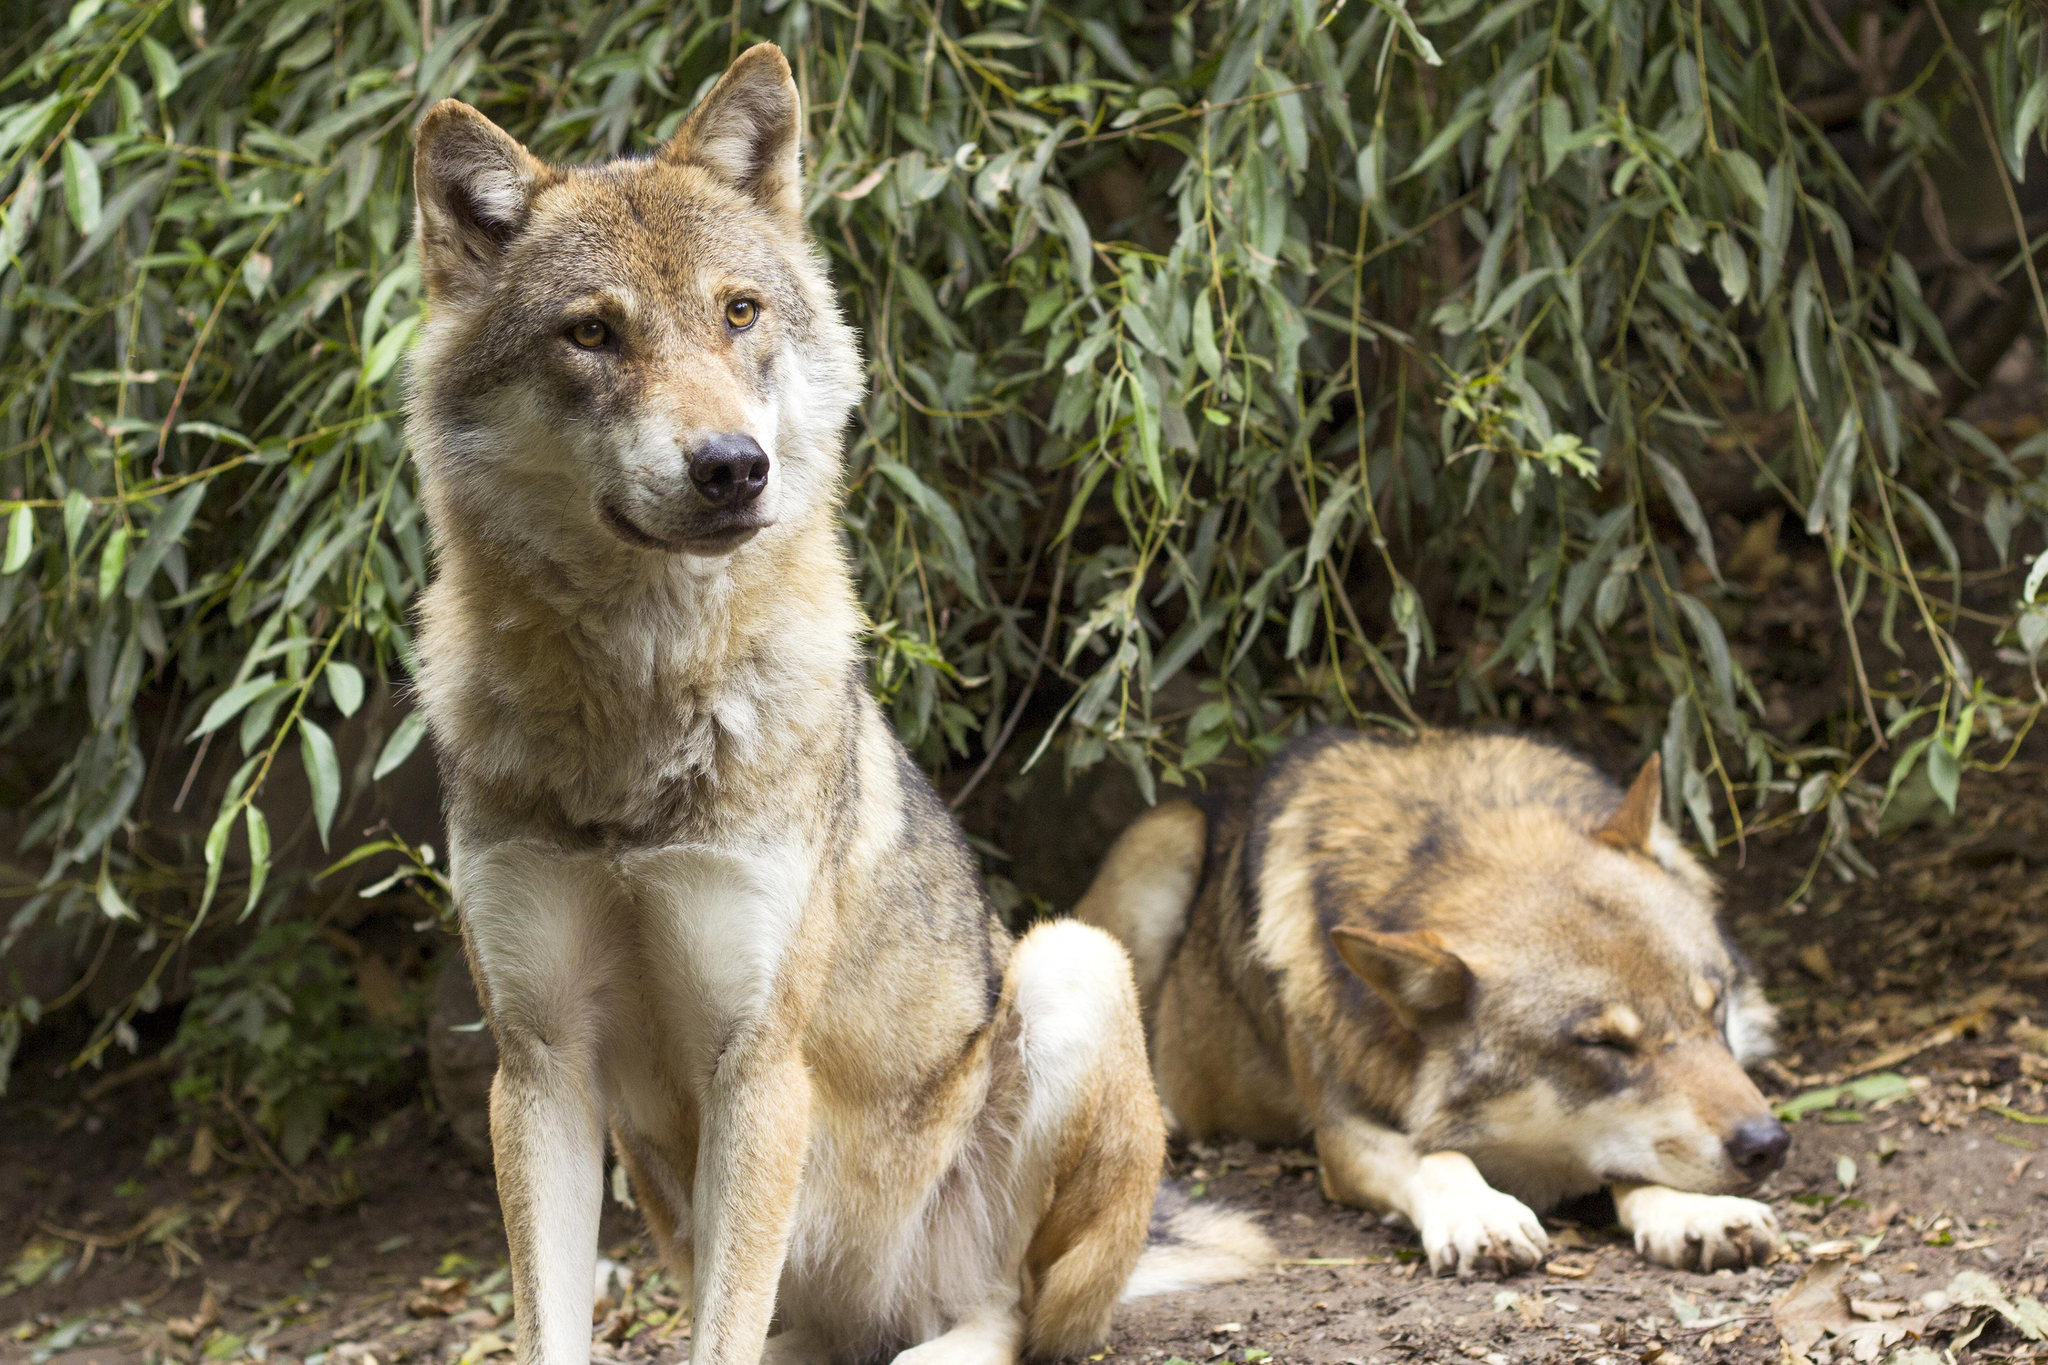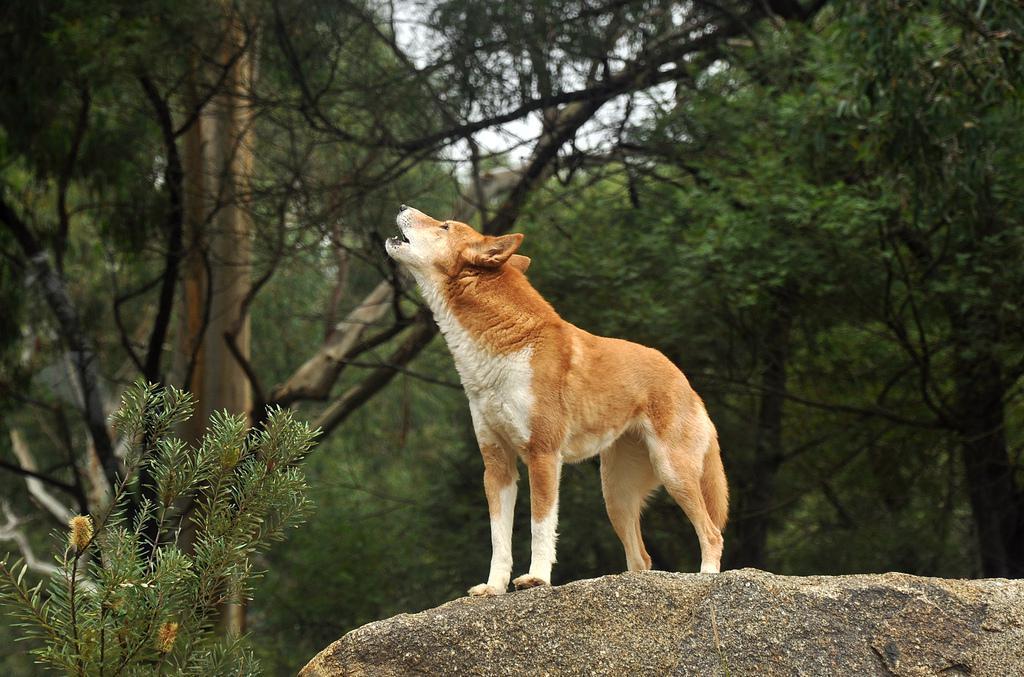The first image is the image on the left, the second image is the image on the right. Examine the images to the left and right. Is the description "A single dog stands on a rock in the image on the right." accurate? Answer yes or no. Yes. The first image is the image on the left, the second image is the image on the right. For the images shown, is this caption "An image includes a dog sleeping on the ground." true? Answer yes or no. Yes. 